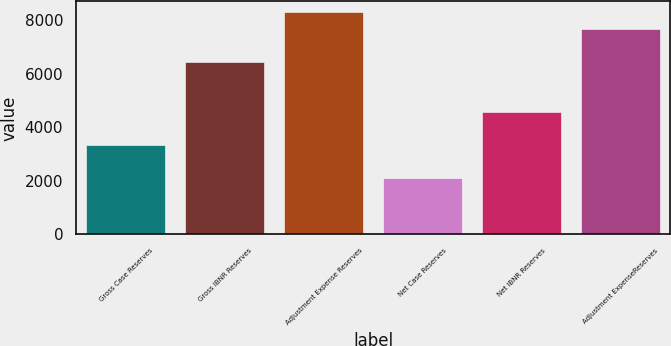<chart> <loc_0><loc_0><loc_500><loc_500><bar_chart><fcel>Gross Case Reserves<fcel>Gross IBNR Reserves<fcel>Adjustment Expense Reserves<fcel>Net Case Reserves<fcel>Net IBNR Reserves<fcel>Adjustment ExpenseReserves<nl><fcel>3328.4<fcel>6424.4<fcel>8282<fcel>2090<fcel>4566.8<fcel>7662.8<nl></chart> 